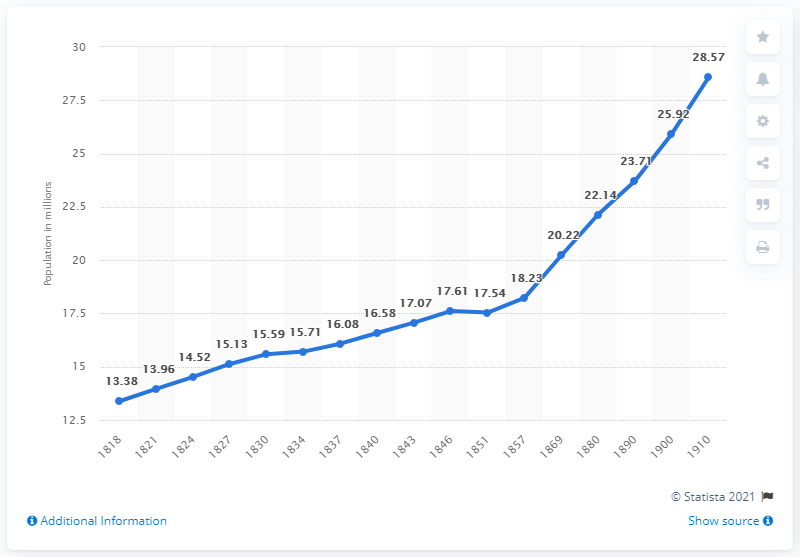Mention a couple of crucial points in this snapshot. In 1910, the population of Austria, specifically Cisleithania, was 28.57. 